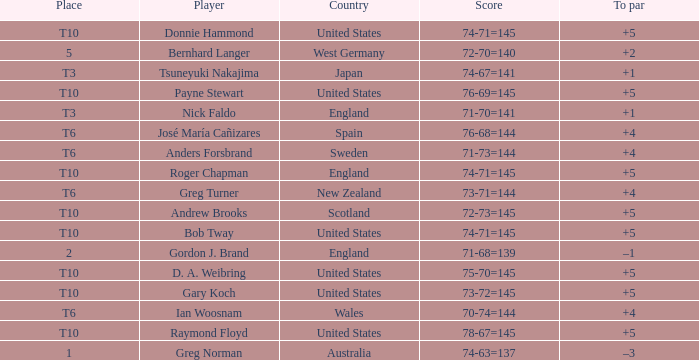Which player scored 76-68=144? José María Cañizares. 